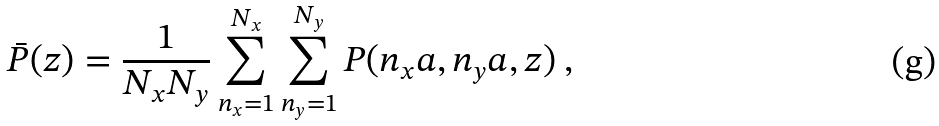Convert formula to latex. <formula><loc_0><loc_0><loc_500><loc_500>\bar { P } ( z ) = \frac { 1 } { N _ { x } N _ { y } } \sum _ { n _ { x } = 1 } ^ { N _ { x } } \sum _ { n _ { y } = 1 } ^ { N _ { y } } P ( n _ { x } a , n _ { y } a , z ) \ ,</formula> 